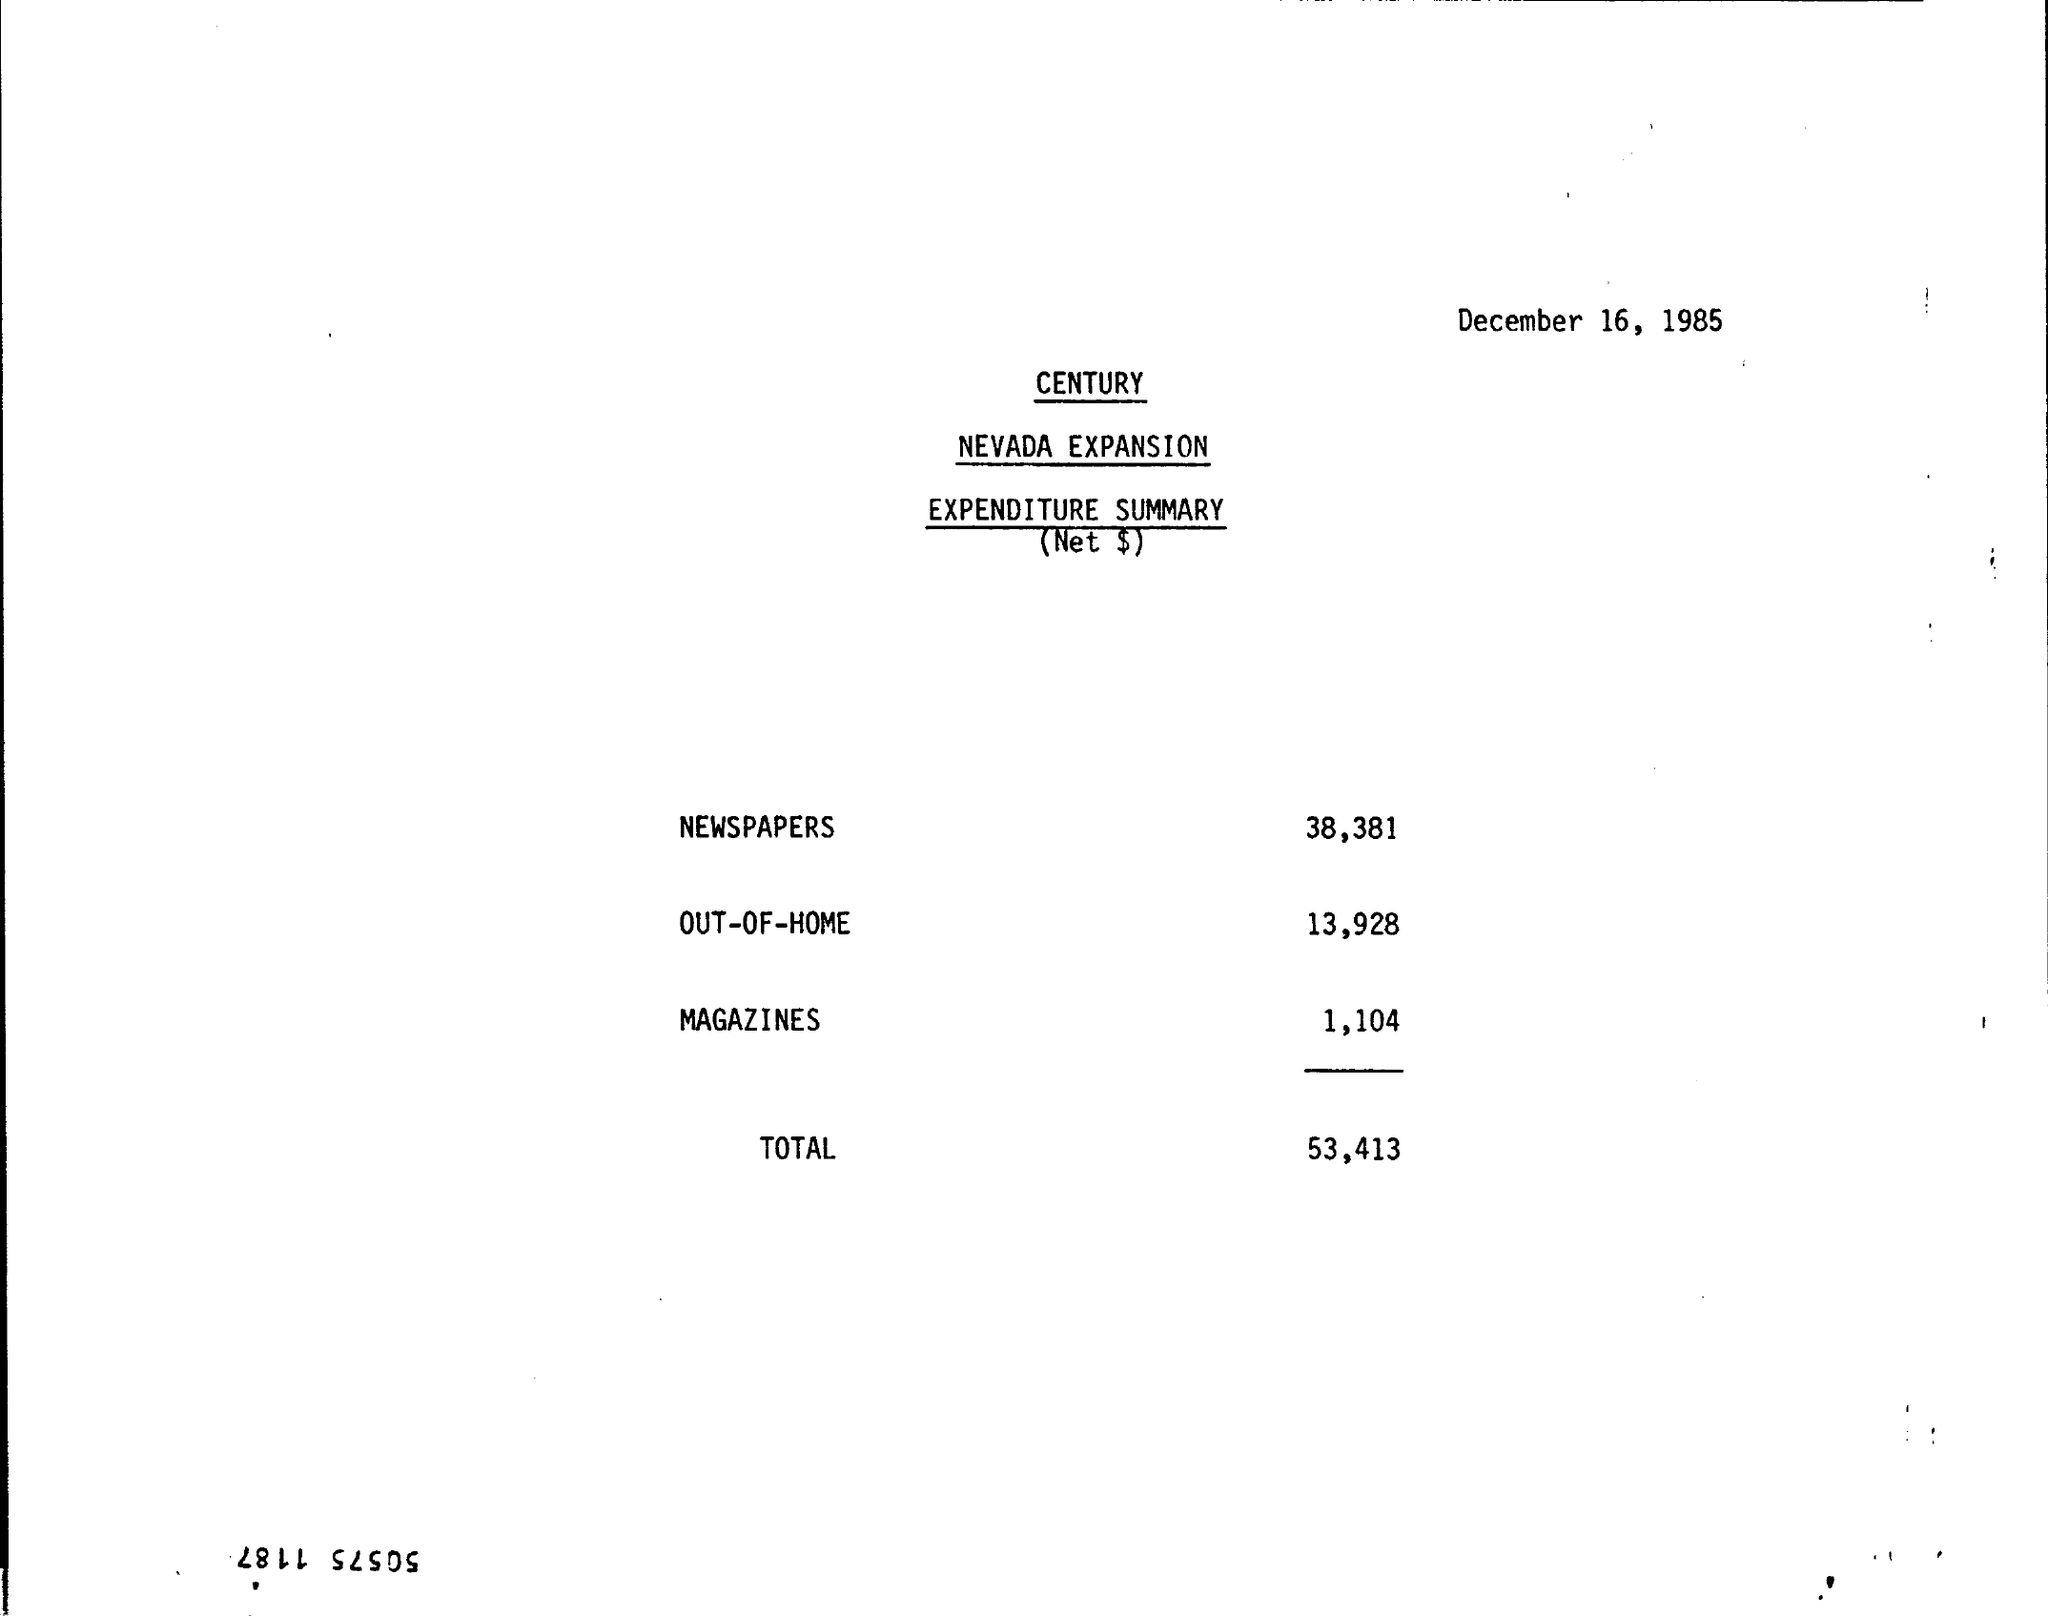What is the Magazines expense ?
 1,104 